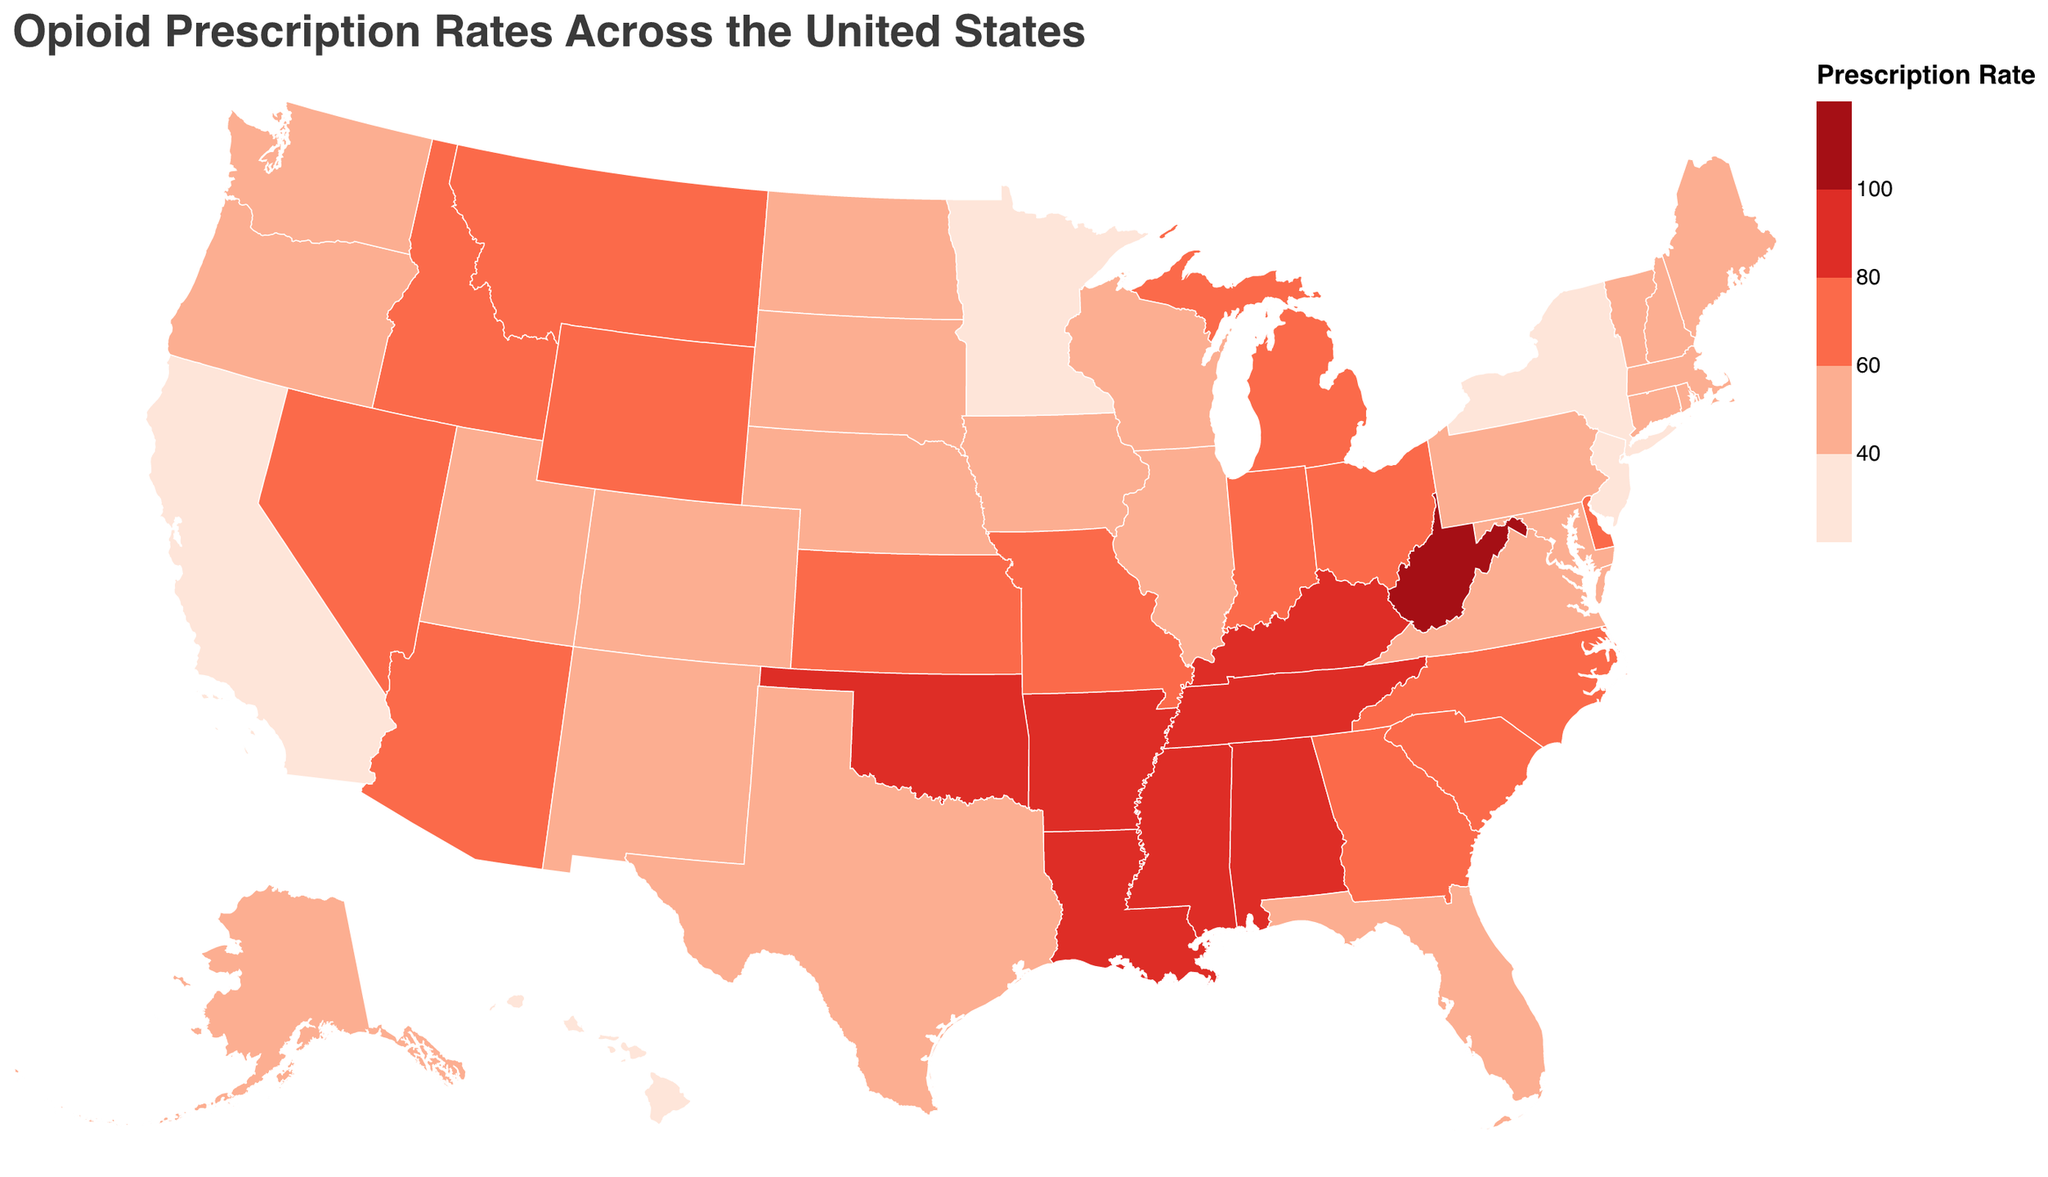Which state has the highest opioid prescription rate? To determine the state with the highest opioid prescription rate, refer to the data by examining the highest rate. West Virginia stands out with a rate of 110.3 per 100 persons.
Answer: West Virginia What is the opioid prescription rate for California? Locate California in the dataset. The figure shows that California's opioid prescription rate is 35.1 per 100 persons.
Answer: 35.1 Which states have opioid prescription rates greater than 90 per 100 persons? By examining the dataset, the states with rates greater than 90 are Alabama (97.5), Arkansas (93.5), Mississippi (92.9), Tennessee (94.4), Louisiana (89.5), Oklahoma (88.1), and West Virginia (110.3).
Answer: Alabama, Arkansas, Mississippi, Tennessee, West Virginia How does the opioid prescription rate of New York compare to New Jersey? The opioid prescription rate for New York is 34.0 per 100 persons and for New Jersey, it is 39.5 per 100 persons. Comparing these, New York has a lower rate than New Jersey.
Answer: New York has a lower rate than New Jersey What is the average opioid prescription rate for the states in the Northeast region (e.g., New York, New Jersey, Pennsylvania, Massachusetts)? Northeast states include New York (34.0), New Jersey (39.5), Pennsylvania (57.7), and Massachusetts (40.1). The average rate is calculated as follows: (34.0 + 39.5 + 57.7 + 40.1) / 4 = 42.825.
Answer: 42.8 Which states have the lowest and highest opioid prescription rates? By reviewing the dataset, New York has the lowest at 34.0 per 100 persons, and West Virginia has the highest at 110.3 per 100 persons.
Answer: New York (lowest), West Virginia (highest) What is the color used to represent states with an opioid prescription rate above 100 per 100 persons? The color scheme ranges from light pink to dark red. The states with rates above 100 are represented in a deep dark red.
Answer: Deep dark red How many states have an opioid prescription rate between 40 and 60 per 100 persons? From the data, states in this range are Alaska, Connecticut, Delaware, Florida, Illinois, Iowa, Maine, Maryland, New Hampshire, New Mexico, Vermont, and Virginia which totals to 12 states.
Answer: 12 Can you identify any geographic patterns in opioid prescription rates from the map? Review the color distribution across the map. Higher rates are concentrated in the southeastern region of the U.S (e.g., Alabama, Tennessee, Kentucky), whereas lower rates are found in the northeastern and western states (e.g., California, New York).
Answer: Higher in the Southeast, lower in the Northeast and West What is the total opioid prescription rate for the five states with the highest rates? The highest rates are in West Virginia (110.3), Alabama (97.5), Tennessee (94.4), Arkansas (93.5), and Mississippi (92.9). The total is calculated as 110.3 + 97.5 + 94.4 + 93.5 + 92.9 = 488.6.
Answer: 488.6 